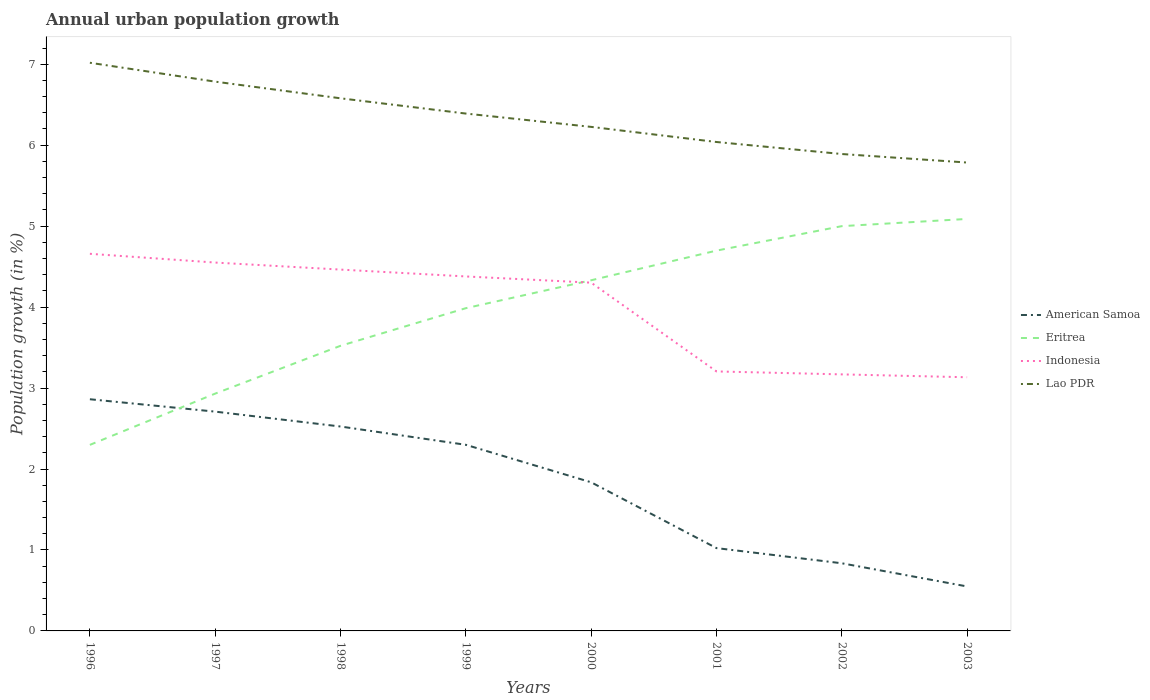How many different coloured lines are there?
Provide a succinct answer. 4. Is the number of lines equal to the number of legend labels?
Provide a succinct answer. Yes. Across all years, what is the maximum percentage of urban population growth in Indonesia?
Offer a terse response. 3.13. In which year was the percentage of urban population growth in Lao PDR maximum?
Your answer should be compact. 2003. What is the total percentage of urban population growth in American Samoa in the graph?
Keep it short and to the point. 2.16. What is the difference between the highest and the second highest percentage of urban population growth in Indonesia?
Your answer should be compact. 1.52. How many years are there in the graph?
Provide a short and direct response. 8. What is the difference between two consecutive major ticks on the Y-axis?
Keep it short and to the point. 1. Are the values on the major ticks of Y-axis written in scientific E-notation?
Provide a short and direct response. No. Where does the legend appear in the graph?
Provide a short and direct response. Center right. How are the legend labels stacked?
Offer a very short reply. Vertical. What is the title of the graph?
Provide a short and direct response. Annual urban population growth. Does "Namibia" appear as one of the legend labels in the graph?
Keep it short and to the point. No. What is the label or title of the X-axis?
Ensure brevity in your answer.  Years. What is the label or title of the Y-axis?
Keep it short and to the point. Population growth (in %). What is the Population growth (in %) in American Samoa in 1996?
Provide a short and direct response. 2.86. What is the Population growth (in %) of Eritrea in 1996?
Provide a succinct answer. 2.3. What is the Population growth (in %) in Indonesia in 1996?
Your answer should be compact. 4.66. What is the Population growth (in %) in Lao PDR in 1996?
Provide a short and direct response. 7.02. What is the Population growth (in %) in American Samoa in 1997?
Offer a very short reply. 2.71. What is the Population growth (in %) in Eritrea in 1997?
Offer a terse response. 2.93. What is the Population growth (in %) of Indonesia in 1997?
Offer a very short reply. 4.55. What is the Population growth (in %) of Lao PDR in 1997?
Your answer should be very brief. 6.78. What is the Population growth (in %) in American Samoa in 1998?
Offer a very short reply. 2.52. What is the Population growth (in %) of Eritrea in 1998?
Make the answer very short. 3.52. What is the Population growth (in %) of Indonesia in 1998?
Ensure brevity in your answer.  4.46. What is the Population growth (in %) of Lao PDR in 1998?
Your answer should be compact. 6.58. What is the Population growth (in %) in American Samoa in 1999?
Ensure brevity in your answer.  2.3. What is the Population growth (in %) in Eritrea in 1999?
Your response must be concise. 3.99. What is the Population growth (in %) in Indonesia in 1999?
Your answer should be very brief. 4.38. What is the Population growth (in %) in Lao PDR in 1999?
Ensure brevity in your answer.  6.39. What is the Population growth (in %) in American Samoa in 2000?
Keep it short and to the point. 1.84. What is the Population growth (in %) of Eritrea in 2000?
Keep it short and to the point. 4.33. What is the Population growth (in %) of Indonesia in 2000?
Offer a terse response. 4.3. What is the Population growth (in %) in Lao PDR in 2000?
Make the answer very short. 6.23. What is the Population growth (in %) of American Samoa in 2001?
Offer a very short reply. 1.02. What is the Population growth (in %) in Eritrea in 2001?
Offer a very short reply. 4.7. What is the Population growth (in %) of Indonesia in 2001?
Your response must be concise. 3.21. What is the Population growth (in %) of Lao PDR in 2001?
Give a very brief answer. 6.04. What is the Population growth (in %) in American Samoa in 2002?
Provide a succinct answer. 0.84. What is the Population growth (in %) of Eritrea in 2002?
Offer a terse response. 5. What is the Population growth (in %) of Indonesia in 2002?
Your answer should be very brief. 3.17. What is the Population growth (in %) of Lao PDR in 2002?
Give a very brief answer. 5.89. What is the Population growth (in %) in American Samoa in 2003?
Make the answer very short. 0.55. What is the Population growth (in %) in Eritrea in 2003?
Offer a terse response. 5.09. What is the Population growth (in %) of Indonesia in 2003?
Offer a terse response. 3.13. What is the Population growth (in %) in Lao PDR in 2003?
Offer a very short reply. 5.79. Across all years, what is the maximum Population growth (in %) in American Samoa?
Give a very brief answer. 2.86. Across all years, what is the maximum Population growth (in %) in Eritrea?
Provide a short and direct response. 5.09. Across all years, what is the maximum Population growth (in %) in Indonesia?
Offer a terse response. 4.66. Across all years, what is the maximum Population growth (in %) of Lao PDR?
Give a very brief answer. 7.02. Across all years, what is the minimum Population growth (in %) in American Samoa?
Your answer should be very brief. 0.55. Across all years, what is the minimum Population growth (in %) of Eritrea?
Your answer should be compact. 2.3. Across all years, what is the minimum Population growth (in %) of Indonesia?
Make the answer very short. 3.13. Across all years, what is the minimum Population growth (in %) in Lao PDR?
Offer a very short reply. 5.79. What is the total Population growth (in %) in American Samoa in the graph?
Provide a succinct answer. 14.64. What is the total Population growth (in %) of Eritrea in the graph?
Your response must be concise. 31.85. What is the total Population growth (in %) in Indonesia in the graph?
Make the answer very short. 31.86. What is the total Population growth (in %) in Lao PDR in the graph?
Give a very brief answer. 50.71. What is the difference between the Population growth (in %) of American Samoa in 1996 and that in 1997?
Provide a short and direct response. 0.15. What is the difference between the Population growth (in %) in Eritrea in 1996 and that in 1997?
Your answer should be compact. -0.63. What is the difference between the Population growth (in %) of Indonesia in 1996 and that in 1997?
Keep it short and to the point. 0.11. What is the difference between the Population growth (in %) in Lao PDR in 1996 and that in 1997?
Your answer should be very brief. 0.23. What is the difference between the Population growth (in %) of American Samoa in 1996 and that in 1998?
Provide a succinct answer. 0.34. What is the difference between the Population growth (in %) in Eritrea in 1996 and that in 1998?
Offer a terse response. -1.22. What is the difference between the Population growth (in %) in Indonesia in 1996 and that in 1998?
Keep it short and to the point. 0.2. What is the difference between the Population growth (in %) of Lao PDR in 1996 and that in 1998?
Give a very brief answer. 0.44. What is the difference between the Population growth (in %) of American Samoa in 1996 and that in 1999?
Provide a short and direct response. 0.56. What is the difference between the Population growth (in %) of Eritrea in 1996 and that in 1999?
Provide a succinct answer. -1.69. What is the difference between the Population growth (in %) of Indonesia in 1996 and that in 1999?
Make the answer very short. 0.28. What is the difference between the Population growth (in %) of Lao PDR in 1996 and that in 1999?
Your response must be concise. 0.63. What is the difference between the Population growth (in %) in American Samoa in 1996 and that in 2000?
Provide a short and direct response. 1.03. What is the difference between the Population growth (in %) in Eritrea in 1996 and that in 2000?
Offer a terse response. -2.03. What is the difference between the Population growth (in %) in Indonesia in 1996 and that in 2000?
Offer a very short reply. 0.36. What is the difference between the Population growth (in %) in Lao PDR in 1996 and that in 2000?
Offer a very short reply. 0.79. What is the difference between the Population growth (in %) in American Samoa in 1996 and that in 2001?
Your answer should be very brief. 1.84. What is the difference between the Population growth (in %) in Eritrea in 1996 and that in 2001?
Offer a terse response. -2.4. What is the difference between the Population growth (in %) in Indonesia in 1996 and that in 2001?
Offer a very short reply. 1.45. What is the difference between the Population growth (in %) in Lao PDR in 1996 and that in 2001?
Give a very brief answer. 0.98. What is the difference between the Population growth (in %) of American Samoa in 1996 and that in 2002?
Your response must be concise. 2.03. What is the difference between the Population growth (in %) in Eritrea in 1996 and that in 2002?
Your answer should be compact. -2.7. What is the difference between the Population growth (in %) of Indonesia in 1996 and that in 2002?
Ensure brevity in your answer.  1.49. What is the difference between the Population growth (in %) of Lao PDR in 1996 and that in 2002?
Keep it short and to the point. 1.13. What is the difference between the Population growth (in %) in American Samoa in 1996 and that in 2003?
Your response must be concise. 2.31. What is the difference between the Population growth (in %) of Eritrea in 1996 and that in 2003?
Give a very brief answer. -2.79. What is the difference between the Population growth (in %) of Indonesia in 1996 and that in 2003?
Offer a very short reply. 1.52. What is the difference between the Population growth (in %) in Lao PDR in 1996 and that in 2003?
Your answer should be compact. 1.23. What is the difference between the Population growth (in %) of American Samoa in 1997 and that in 1998?
Your answer should be compact. 0.18. What is the difference between the Population growth (in %) of Eritrea in 1997 and that in 1998?
Your answer should be compact. -0.59. What is the difference between the Population growth (in %) in Indonesia in 1997 and that in 1998?
Your answer should be very brief. 0.09. What is the difference between the Population growth (in %) in Lao PDR in 1997 and that in 1998?
Offer a very short reply. 0.21. What is the difference between the Population growth (in %) of American Samoa in 1997 and that in 1999?
Provide a succinct answer. 0.41. What is the difference between the Population growth (in %) in Eritrea in 1997 and that in 1999?
Provide a short and direct response. -1.06. What is the difference between the Population growth (in %) in Indonesia in 1997 and that in 1999?
Provide a succinct answer. 0.17. What is the difference between the Population growth (in %) in Lao PDR in 1997 and that in 1999?
Offer a very short reply. 0.39. What is the difference between the Population growth (in %) of American Samoa in 1997 and that in 2000?
Your answer should be compact. 0.87. What is the difference between the Population growth (in %) in Eritrea in 1997 and that in 2000?
Ensure brevity in your answer.  -1.4. What is the difference between the Population growth (in %) in Indonesia in 1997 and that in 2000?
Your answer should be very brief. 0.25. What is the difference between the Population growth (in %) in Lao PDR in 1997 and that in 2000?
Ensure brevity in your answer.  0.56. What is the difference between the Population growth (in %) in American Samoa in 1997 and that in 2001?
Your answer should be very brief. 1.69. What is the difference between the Population growth (in %) in Eritrea in 1997 and that in 2001?
Provide a succinct answer. -1.77. What is the difference between the Population growth (in %) of Indonesia in 1997 and that in 2001?
Provide a short and direct response. 1.34. What is the difference between the Population growth (in %) in Lao PDR in 1997 and that in 2001?
Provide a short and direct response. 0.75. What is the difference between the Population growth (in %) in American Samoa in 1997 and that in 2002?
Your response must be concise. 1.87. What is the difference between the Population growth (in %) in Eritrea in 1997 and that in 2002?
Offer a terse response. -2.07. What is the difference between the Population growth (in %) in Indonesia in 1997 and that in 2002?
Provide a short and direct response. 1.38. What is the difference between the Population growth (in %) in Lao PDR in 1997 and that in 2002?
Your answer should be very brief. 0.89. What is the difference between the Population growth (in %) of American Samoa in 1997 and that in 2003?
Your response must be concise. 2.16. What is the difference between the Population growth (in %) in Eritrea in 1997 and that in 2003?
Ensure brevity in your answer.  -2.16. What is the difference between the Population growth (in %) of Indonesia in 1997 and that in 2003?
Your response must be concise. 1.42. What is the difference between the Population growth (in %) in Lao PDR in 1997 and that in 2003?
Your answer should be compact. 1. What is the difference between the Population growth (in %) of American Samoa in 1998 and that in 1999?
Keep it short and to the point. 0.23. What is the difference between the Population growth (in %) in Eritrea in 1998 and that in 1999?
Provide a succinct answer. -0.46. What is the difference between the Population growth (in %) in Indonesia in 1998 and that in 1999?
Your answer should be very brief. 0.08. What is the difference between the Population growth (in %) in Lao PDR in 1998 and that in 1999?
Your response must be concise. 0.19. What is the difference between the Population growth (in %) in American Samoa in 1998 and that in 2000?
Ensure brevity in your answer.  0.69. What is the difference between the Population growth (in %) of Eritrea in 1998 and that in 2000?
Give a very brief answer. -0.81. What is the difference between the Population growth (in %) of Indonesia in 1998 and that in 2000?
Provide a succinct answer. 0.16. What is the difference between the Population growth (in %) in Lao PDR in 1998 and that in 2000?
Offer a very short reply. 0.35. What is the difference between the Population growth (in %) in American Samoa in 1998 and that in 2001?
Your answer should be compact. 1.5. What is the difference between the Population growth (in %) of Eritrea in 1998 and that in 2001?
Give a very brief answer. -1.18. What is the difference between the Population growth (in %) in Indonesia in 1998 and that in 2001?
Provide a short and direct response. 1.26. What is the difference between the Population growth (in %) of Lao PDR in 1998 and that in 2001?
Your answer should be compact. 0.54. What is the difference between the Population growth (in %) in American Samoa in 1998 and that in 2002?
Keep it short and to the point. 1.69. What is the difference between the Population growth (in %) of Eritrea in 1998 and that in 2002?
Your answer should be compact. -1.48. What is the difference between the Population growth (in %) of Indonesia in 1998 and that in 2002?
Offer a very short reply. 1.29. What is the difference between the Population growth (in %) of Lao PDR in 1998 and that in 2002?
Your response must be concise. 0.69. What is the difference between the Population growth (in %) in American Samoa in 1998 and that in 2003?
Provide a succinct answer. 1.98. What is the difference between the Population growth (in %) in Eritrea in 1998 and that in 2003?
Give a very brief answer. -1.57. What is the difference between the Population growth (in %) of Indonesia in 1998 and that in 2003?
Provide a succinct answer. 1.33. What is the difference between the Population growth (in %) in Lao PDR in 1998 and that in 2003?
Provide a succinct answer. 0.79. What is the difference between the Population growth (in %) of American Samoa in 1999 and that in 2000?
Make the answer very short. 0.46. What is the difference between the Population growth (in %) of Eritrea in 1999 and that in 2000?
Your response must be concise. -0.34. What is the difference between the Population growth (in %) of Indonesia in 1999 and that in 2000?
Ensure brevity in your answer.  0.08. What is the difference between the Population growth (in %) of Lao PDR in 1999 and that in 2000?
Offer a terse response. 0.16. What is the difference between the Population growth (in %) in American Samoa in 1999 and that in 2001?
Your response must be concise. 1.28. What is the difference between the Population growth (in %) of Eritrea in 1999 and that in 2001?
Your response must be concise. -0.71. What is the difference between the Population growth (in %) in Indonesia in 1999 and that in 2001?
Keep it short and to the point. 1.17. What is the difference between the Population growth (in %) of Lao PDR in 1999 and that in 2001?
Provide a short and direct response. 0.35. What is the difference between the Population growth (in %) in American Samoa in 1999 and that in 2002?
Provide a short and direct response. 1.46. What is the difference between the Population growth (in %) in Eritrea in 1999 and that in 2002?
Your answer should be compact. -1.01. What is the difference between the Population growth (in %) in Indonesia in 1999 and that in 2002?
Your answer should be very brief. 1.21. What is the difference between the Population growth (in %) in Lao PDR in 1999 and that in 2002?
Keep it short and to the point. 0.5. What is the difference between the Population growth (in %) in American Samoa in 1999 and that in 2003?
Your answer should be compact. 1.75. What is the difference between the Population growth (in %) of Eritrea in 1999 and that in 2003?
Your response must be concise. -1.1. What is the difference between the Population growth (in %) in Indonesia in 1999 and that in 2003?
Your response must be concise. 1.25. What is the difference between the Population growth (in %) in Lao PDR in 1999 and that in 2003?
Keep it short and to the point. 0.6. What is the difference between the Population growth (in %) of American Samoa in 2000 and that in 2001?
Make the answer very short. 0.81. What is the difference between the Population growth (in %) of Eritrea in 2000 and that in 2001?
Keep it short and to the point. -0.37. What is the difference between the Population growth (in %) of Indonesia in 2000 and that in 2001?
Your answer should be compact. 1.1. What is the difference between the Population growth (in %) in Lao PDR in 2000 and that in 2001?
Your answer should be compact. 0.19. What is the difference between the Population growth (in %) in Eritrea in 2000 and that in 2002?
Give a very brief answer. -0.67. What is the difference between the Population growth (in %) in Indonesia in 2000 and that in 2002?
Keep it short and to the point. 1.13. What is the difference between the Population growth (in %) in Lao PDR in 2000 and that in 2002?
Make the answer very short. 0.34. What is the difference between the Population growth (in %) of American Samoa in 2000 and that in 2003?
Provide a succinct answer. 1.29. What is the difference between the Population growth (in %) of Eritrea in 2000 and that in 2003?
Offer a terse response. -0.76. What is the difference between the Population growth (in %) of Indonesia in 2000 and that in 2003?
Your answer should be compact. 1.17. What is the difference between the Population growth (in %) in Lao PDR in 2000 and that in 2003?
Your response must be concise. 0.44. What is the difference between the Population growth (in %) of American Samoa in 2001 and that in 2002?
Your response must be concise. 0.19. What is the difference between the Population growth (in %) in Eritrea in 2001 and that in 2002?
Your response must be concise. -0.3. What is the difference between the Population growth (in %) in Indonesia in 2001 and that in 2002?
Your answer should be compact. 0.04. What is the difference between the Population growth (in %) in Lao PDR in 2001 and that in 2002?
Keep it short and to the point. 0.15. What is the difference between the Population growth (in %) of American Samoa in 2001 and that in 2003?
Offer a terse response. 0.47. What is the difference between the Population growth (in %) of Eritrea in 2001 and that in 2003?
Your answer should be very brief. -0.39. What is the difference between the Population growth (in %) in Indonesia in 2001 and that in 2003?
Your answer should be compact. 0.07. What is the difference between the Population growth (in %) of Lao PDR in 2001 and that in 2003?
Your answer should be compact. 0.25. What is the difference between the Population growth (in %) of American Samoa in 2002 and that in 2003?
Your answer should be very brief. 0.29. What is the difference between the Population growth (in %) in Eritrea in 2002 and that in 2003?
Offer a very short reply. -0.09. What is the difference between the Population growth (in %) in Indonesia in 2002 and that in 2003?
Your response must be concise. 0.04. What is the difference between the Population growth (in %) in Lao PDR in 2002 and that in 2003?
Keep it short and to the point. 0.11. What is the difference between the Population growth (in %) in American Samoa in 1996 and the Population growth (in %) in Eritrea in 1997?
Offer a terse response. -0.07. What is the difference between the Population growth (in %) of American Samoa in 1996 and the Population growth (in %) of Indonesia in 1997?
Your answer should be compact. -1.69. What is the difference between the Population growth (in %) in American Samoa in 1996 and the Population growth (in %) in Lao PDR in 1997?
Ensure brevity in your answer.  -3.92. What is the difference between the Population growth (in %) in Eritrea in 1996 and the Population growth (in %) in Indonesia in 1997?
Your response must be concise. -2.25. What is the difference between the Population growth (in %) of Eritrea in 1996 and the Population growth (in %) of Lao PDR in 1997?
Ensure brevity in your answer.  -4.49. What is the difference between the Population growth (in %) in Indonesia in 1996 and the Population growth (in %) in Lao PDR in 1997?
Offer a very short reply. -2.13. What is the difference between the Population growth (in %) in American Samoa in 1996 and the Population growth (in %) in Eritrea in 1998?
Your response must be concise. -0.66. What is the difference between the Population growth (in %) in American Samoa in 1996 and the Population growth (in %) in Indonesia in 1998?
Give a very brief answer. -1.6. What is the difference between the Population growth (in %) of American Samoa in 1996 and the Population growth (in %) of Lao PDR in 1998?
Offer a very short reply. -3.72. What is the difference between the Population growth (in %) in Eritrea in 1996 and the Population growth (in %) in Indonesia in 1998?
Make the answer very short. -2.17. What is the difference between the Population growth (in %) in Eritrea in 1996 and the Population growth (in %) in Lao PDR in 1998?
Give a very brief answer. -4.28. What is the difference between the Population growth (in %) in Indonesia in 1996 and the Population growth (in %) in Lao PDR in 1998?
Provide a short and direct response. -1.92. What is the difference between the Population growth (in %) of American Samoa in 1996 and the Population growth (in %) of Eritrea in 1999?
Ensure brevity in your answer.  -1.12. What is the difference between the Population growth (in %) of American Samoa in 1996 and the Population growth (in %) of Indonesia in 1999?
Your answer should be very brief. -1.52. What is the difference between the Population growth (in %) in American Samoa in 1996 and the Population growth (in %) in Lao PDR in 1999?
Make the answer very short. -3.53. What is the difference between the Population growth (in %) of Eritrea in 1996 and the Population growth (in %) of Indonesia in 1999?
Make the answer very short. -2.08. What is the difference between the Population growth (in %) in Eritrea in 1996 and the Population growth (in %) in Lao PDR in 1999?
Make the answer very short. -4.09. What is the difference between the Population growth (in %) in Indonesia in 1996 and the Population growth (in %) in Lao PDR in 1999?
Provide a short and direct response. -1.73. What is the difference between the Population growth (in %) in American Samoa in 1996 and the Population growth (in %) in Eritrea in 2000?
Make the answer very short. -1.47. What is the difference between the Population growth (in %) in American Samoa in 1996 and the Population growth (in %) in Indonesia in 2000?
Your answer should be very brief. -1.44. What is the difference between the Population growth (in %) in American Samoa in 1996 and the Population growth (in %) in Lao PDR in 2000?
Provide a short and direct response. -3.36. What is the difference between the Population growth (in %) of Eritrea in 1996 and the Population growth (in %) of Indonesia in 2000?
Ensure brevity in your answer.  -2. What is the difference between the Population growth (in %) of Eritrea in 1996 and the Population growth (in %) of Lao PDR in 2000?
Offer a terse response. -3.93. What is the difference between the Population growth (in %) of Indonesia in 1996 and the Population growth (in %) of Lao PDR in 2000?
Offer a very short reply. -1.57. What is the difference between the Population growth (in %) in American Samoa in 1996 and the Population growth (in %) in Eritrea in 2001?
Ensure brevity in your answer.  -1.84. What is the difference between the Population growth (in %) in American Samoa in 1996 and the Population growth (in %) in Indonesia in 2001?
Keep it short and to the point. -0.34. What is the difference between the Population growth (in %) of American Samoa in 1996 and the Population growth (in %) of Lao PDR in 2001?
Provide a short and direct response. -3.18. What is the difference between the Population growth (in %) of Eritrea in 1996 and the Population growth (in %) of Indonesia in 2001?
Your answer should be very brief. -0.91. What is the difference between the Population growth (in %) in Eritrea in 1996 and the Population growth (in %) in Lao PDR in 2001?
Offer a very short reply. -3.74. What is the difference between the Population growth (in %) in Indonesia in 1996 and the Population growth (in %) in Lao PDR in 2001?
Ensure brevity in your answer.  -1.38. What is the difference between the Population growth (in %) in American Samoa in 1996 and the Population growth (in %) in Eritrea in 2002?
Provide a succinct answer. -2.14. What is the difference between the Population growth (in %) of American Samoa in 1996 and the Population growth (in %) of Indonesia in 2002?
Provide a succinct answer. -0.31. What is the difference between the Population growth (in %) of American Samoa in 1996 and the Population growth (in %) of Lao PDR in 2002?
Keep it short and to the point. -3.03. What is the difference between the Population growth (in %) of Eritrea in 1996 and the Population growth (in %) of Indonesia in 2002?
Offer a very short reply. -0.87. What is the difference between the Population growth (in %) of Eritrea in 1996 and the Population growth (in %) of Lao PDR in 2002?
Keep it short and to the point. -3.59. What is the difference between the Population growth (in %) of Indonesia in 1996 and the Population growth (in %) of Lao PDR in 2002?
Make the answer very short. -1.23. What is the difference between the Population growth (in %) in American Samoa in 1996 and the Population growth (in %) in Eritrea in 2003?
Your answer should be very brief. -2.23. What is the difference between the Population growth (in %) of American Samoa in 1996 and the Population growth (in %) of Indonesia in 2003?
Make the answer very short. -0.27. What is the difference between the Population growth (in %) of American Samoa in 1996 and the Population growth (in %) of Lao PDR in 2003?
Make the answer very short. -2.92. What is the difference between the Population growth (in %) of Eritrea in 1996 and the Population growth (in %) of Indonesia in 2003?
Your answer should be very brief. -0.84. What is the difference between the Population growth (in %) in Eritrea in 1996 and the Population growth (in %) in Lao PDR in 2003?
Your response must be concise. -3.49. What is the difference between the Population growth (in %) of Indonesia in 1996 and the Population growth (in %) of Lao PDR in 2003?
Provide a short and direct response. -1.13. What is the difference between the Population growth (in %) in American Samoa in 1997 and the Population growth (in %) in Eritrea in 1998?
Keep it short and to the point. -0.81. What is the difference between the Population growth (in %) of American Samoa in 1997 and the Population growth (in %) of Indonesia in 1998?
Offer a very short reply. -1.75. What is the difference between the Population growth (in %) in American Samoa in 1997 and the Population growth (in %) in Lao PDR in 1998?
Ensure brevity in your answer.  -3.87. What is the difference between the Population growth (in %) in Eritrea in 1997 and the Population growth (in %) in Indonesia in 1998?
Provide a succinct answer. -1.53. What is the difference between the Population growth (in %) in Eritrea in 1997 and the Population growth (in %) in Lao PDR in 1998?
Give a very brief answer. -3.65. What is the difference between the Population growth (in %) of Indonesia in 1997 and the Population growth (in %) of Lao PDR in 1998?
Provide a succinct answer. -2.03. What is the difference between the Population growth (in %) in American Samoa in 1997 and the Population growth (in %) in Eritrea in 1999?
Make the answer very short. -1.28. What is the difference between the Population growth (in %) in American Samoa in 1997 and the Population growth (in %) in Indonesia in 1999?
Your answer should be compact. -1.67. What is the difference between the Population growth (in %) of American Samoa in 1997 and the Population growth (in %) of Lao PDR in 1999?
Make the answer very short. -3.68. What is the difference between the Population growth (in %) of Eritrea in 1997 and the Population growth (in %) of Indonesia in 1999?
Ensure brevity in your answer.  -1.45. What is the difference between the Population growth (in %) of Eritrea in 1997 and the Population growth (in %) of Lao PDR in 1999?
Make the answer very short. -3.46. What is the difference between the Population growth (in %) of Indonesia in 1997 and the Population growth (in %) of Lao PDR in 1999?
Keep it short and to the point. -1.84. What is the difference between the Population growth (in %) of American Samoa in 1997 and the Population growth (in %) of Eritrea in 2000?
Provide a short and direct response. -1.62. What is the difference between the Population growth (in %) in American Samoa in 1997 and the Population growth (in %) in Indonesia in 2000?
Offer a terse response. -1.59. What is the difference between the Population growth (in %) in American Samoa in 1997 and the Population growth (in %) in Lao PDR in 2000?
Your response must be concise. -3.52. What is the difference between the Population growth (in %) in Eritrea in 1997 and the Population growth (in %) in Indonesia in 2000?
Make the answer very short. -1.37. What is the difference between the Population growth (in %) of Eritrea in 1997 and the Population growth (in %) of Lao PDR in 2000?
Make the answer very short. -3.29. What is the difference between the Population growth (in %) in Indonesia in 1997 and the Population growth (in %) in Lao PDR in 2000?
Provide a succinct answer. -1.68. What is the difference between the Population growth (in %) in American Samoa in 1997 and the Population growth (in %) in Eritrea in 2001?
Provide a short and direct response. -1.99. What is the difference between the Population growth (in %) in American Samoa in 1997 and the Population growth (in %) in Indonesia in 2001?
Your answer should be very brief. -0.5. What is the difference between the Population growth (in %) of American Samoa in 1997 and the Population growth (in %) of Lao PDR in 2001?
Keep it short and to the point. -3.33. What is the difference between the Population growth (in %) in Eritrea in 1997 and the Population growth (in %) in Indonesia in 2001?
Give a very brief answer. -0.27. What is the difference between the Population growth (in %) of Eritrea in 1997 and the Population growth (in %) of Lao PDR in 2001?
Provide a succinct answer. -3.11. What is the difference between the Population growth (in %) in Indonesia in 1997 and the Population growth (in %) in Lao PDR in 2001?
Give a very brief answer. -1.49. What is the difference between the Population growth (in %) of American Samoa in 1997 and the Population growth (in %) of Eritrea in 2002?
Your response must be concise. -2.29. What is the difference between the Population growth (in %) of American Samoa in 1997 and the Population growth (in %) of Indonesia in 2002?
Give a very brief answer. -0.46. What is the difference between the Population growth (in %) in American Samoa in 1997 and the Population growth (in %) in Lao PDR in 2002?
Give a very brief answer. -3.18. What is the difference between the Population growth (in %) of Eritrea in 1997 and the Population growth (in %) of Indonesia in 2002?
Offer a very short reply. -0.24. What is the difference between the Population growth (in %) in Eritrea in 1997 and the Population growth (in %) in Lao PDR in 2002?
Give a very brief answer. -2.96. What is the difference between the Population growth (in %) of Indonesia in 1997 and the Population growth (in %) of Lao PDR in 2002?
Give a very brief answer. -1.34. What is the difference between the Population growth (in %) in American Samoa in 1997 and the Population growth (in %) in Eritrea in 2003?
Your answer should be very brief. -2.38. What is the difference between the Population growth (in %) in American Samoa in 1997 and the Population growth (in %) in Indonesia in 2003?
Provide a short and direct response. -0.42. What is the difference between the Population growth (in %) in American Samoa in 1997 and the Population growth (in %) in Lao PDR in 2003?
Ensure brevity in your answer.  -3.08. What is the difference between the Population growth (in %) in Eritrea in 1997 and the Population growth (in %) in Indonesia in 2003?
Make the answer very short. -0.2. What is the difference between the Population growth (in %) of Eritrea in 1997 and the Population growth (in %) of Lao PDR in 2003?
Offer a very short reply. -2.85. What is the difference between the Population growth (in %) in Indonesia in 1997 and the Population growth (in %) in Lao PDR in 2003?
Your answer should be very brief. -1.24. What is the difference between the Population growth (in %) in American Samoa in 1998 and the Population growth (in %) in Eritrea in 1999?
Provide a succinct answer. -1.46. What is the difference between the Population growth (in %) in American Samoa in 1998 and the Population growth (in %) in Indonesia in 1999?
Ensure brevity in your answer.  -1.85. What is the difference between the Population growth (in %) in American Samoa in 1998 and the Population growth (in %) in Lao PDR in 1999?
Your response must be concise. -3.87. What is the difference between the Population growth (in %) of Eritrea in 1998 and the Population growth (in %) of Indonesia in 1999?
Offer a very short reply. -0.86. What is the difference between the Population growth (in %) in Eritrea in 1998 and the Population growth (in %) in Lao PDR in 1999?
Offer a terse response. -2.87. What is the difference between the Population growth (in %) of Indonesia in 1998 and the Population growth (in %) of Lao PDR in 1999?
Your answer should be compact. -1.93. What is the difference between the Population growth (in %) in American Samoa in 1998 and the Population growth (in %) in Eritrea in 2000?
Keep it short and to the point. -1.81. What is the difference between the Population growth (in %) in American Samoa in 1998 and the Population growth (in %) in Indonesia in 2000?
Make the answer very short. -1.78. What is the difference between the Population growth (in %) of American Samoa in 1998 and the Population growth (in %) of Lao PDR in 2000?
Your response must be concise. -3.7. What is the difference between the Population growth (in %) of Eritrea in 1998 and the Population growth (in %) of Indonesia in 2000?
Provide a short and direct response. -0.78. What is the difference between the Population growth (in %) of Eritrea in 1998 and the Population growth (in %) of Lao PDR in 2000?
Provide a succinct answer. -2.7. What is the difference between the Population growth (in %) of Indonesia in 1998 and the Population growth (in %) of Lao PDR in 2000?
Give a very brief answer. -1.76. What is the difference between the Population growth (in %) in American Samoa in 1998 and the Population growth (in %) in Eritrea in 2001?
Provide a short and direct response. -2.17. What is the difference between the Population growth (in %) in American Samoa in 1998 and the Population growth (in %) in Indonesia in 2001?
Your answer should be very brief. -0.68. What is the difference between the Population growth (in %) in American Samoa in 1998 and the Population growth (in %) in Lao PDR in 2001?
Ensure brevity in your answer.  -3.51. What is the difference between the Population growth (in %) in Eritrea in 1998 and the Population growth (in %) in Indonesia in 2001?
Give a very brief answer. 0.32. What is the difference between the Population growth (in %) of Eritrea in 1998 and the Population growth (in %) of Lao PDR in 2001?
Offer a very short reply. -2.52. What is the difference between the Population growth (in %) in Indonesia in 1998 and the Population growth (in %) in Lao PDR in 2001?
Keep it short and to the point. -1.58. What is the difference between the Population growth (in %) in American Samoa in 1998 and the Population growth (in %) in Eritrea in 2002?
Your answer should be very brief. -2.47. What is the difference between the Population growth (in %) in American Samoa in 1998 and the Population growth (in %) in Indonesia in 2002?
Give a very brief answer. -0.64. What is the difference between the Population growth (in %) in American Samoa in 1998 and the Population growth (in %) in Lao PDR in 2002?
Your answer should be very brief. -3.37. What is the difference between the Population growth (in %) in Eritrea in 1998 and the Population growth (in %) in Indonesia in 2002?
Keep it short and to the point. 0.35. What is the difference between the Population growth (in %) in Eritrea in 1998 and the Population growth (in %) in Lao PDR in 2002?
Make the answer very short. -2.37. What is the difference between the Population growth (in %) of Indonesia in 1998 and the Population growth (in %) of Lao PDR in 2002?
Provide a succinct answer. -1.43. What is the difference between the Population growth (in %) of American Samoa in 1998 and the Population growth (in %) of Eritrea in 2003?
Give a very brief answer. -2.56. What is the difference between the Population growth (in %) of American Samoa in 1998 and the Population growth (in %) of Indonesia in 2003?
Give a very brief answer. -0.61. What is the difference between the Population growth (in %) of American Samoa in 1998 and the Population growth (in %) of Lao PDR in 2003?
Provide a short and direct response. -3.26. What is the difference between the Population growth (in %) in Eritrea in 1998 and the Population growth (in %) in Indonesia in 2003?
Keep it short and to the point. 0.39. What is the difference between the Population growth (in %) in Eritrea in 1998 and the Population growth (in %) in Lao PDR in 2003?
Your answer should be compact. -2.26. What is the difference between the Population growth (in %) in Indonesia in 1998 and the Population growth (in %) in Lao PDR in 2003?
Keep it short and to the point. -1.32. What is the difference between the Population growth (in %) of American Samoa in 1999 and the Population growth (in %) of Eritrea in 2000?
Give a very brief answer. -2.03. What is the difference between the Population growth (in %) in American Samoa in 1999 and the Population growth (in %) in Indonesia in 2000?
Give a very brief answer. -2. What is the difference between the Population growth (in %) of American Samoa in 1999 and the Population growth (in %) of Lao PDR in 2000?
Give a very brief answer. -3.93. What is the difference between the Population growth (in %) of Eritrea in 1999 and the Population growth (in %) of Indonesia in 2000?
Your response must be concise. -0.32. What is the difference between the Population growth (in %) in Eritrea in 1999 and the Population growth (in %) in Lao PDR in 2000?
Your response must be concise. -2.24. What is the difference between the Population growth (in %) of Indonesia in 1999 and the Population growth (in %) of Lao PDR in 2000?
Your answer should be very brief. -1.85. What is the difference between the Population growth (in %) in American Samoa in 1999 and the Population growth (in %) in Eritrea in 2001?
Your answer should be compact. -2.4. What is the difference between the Population growth (in %) in American Samoa in 1999 and the Population growth (in %) in Indonesia in 2001?
Give a very brief answer. -0.91. What is the difference between the Population growth (in %) of American Samoa in 1999 and the Population growth (in %) of Lao PDR in 2001?
Ensure brevity in your answer.  -3.74. What is the difference between the Population growth (in %) in Eritrea in 1999 and the Population growth (in %) in Indonesia in 2001?
Provide a short and direct response. 0.78. What is the difference between the Population growth (in %) of Eritrea in 1999 and the Population growth (in %) of Lao PDR in 2001?
Your response must be concise. -2.05. What is the difference between the Population growth (in %) in Indonesia in 1999 and the Population growth (in %) in Lao PDR in 2001?
Offer a very short reply. -1.66. What is the difference between the Population growth (in %) in American Samoa in 1999 and the Population growth (in %) in Eritrea in 2002?
Keep it short and to the point. -2.7. What is the difference between the Population growth (in %) in American Samoa in 1999 and the Population growth (in %) in Indonesia in 2002?
Your answer should be compact. -0.87. What is the difference between the Population growth (in %) of American Samoa in 1999 and the Population growth (in %) of Lao PDR in 2002?
Keep it short and to the point. -3.59. What is the difference between the Population growth (in %) in Eritrea in 1999 and the Population growth (in %) in Indonesia in 2002?
Your answer should be compact. 0.82. What is the difference between the Population growth (in %) in Eritrea in 1999 and the Population growth (in %) in Lao PDR in 2002?
Make the answer very short. -1.9. What is the difference between the Population growth (in %) in Indonesia in 1999 and the Population growth (in %) in Lao PDR in 2002?
Make the answer very short. -1.51. What is the difference between the Population growth (in %) in American Samoa in 1999 and the Population growth (in %) in Eritrea in 2003?
Ensure brevity in your answer.  -2.79. What is the difference between the Population growth (in %) of American Samoa in 1999 and the Population growth (in %) of Indonesia in 2003?
Provide a short and direct response. -0.83. What is the difference between the Population growth (in %) of American Samoa in 1999 and the Population growth (in %) of Lao PDR in 2003?
Offer a terse response. -3.49. What is the difference between the Population growth (in %) of Eritrea in 1999 and the Population growth (in %) of Indonesia in 2003?
Make the answer very short. 0.85. What is the difference between the Population growth (in %) in Eritrea in 1999 and the Population growth (in %) in Lao PDR in 2003?
Offer a very short reply. -1.8. What is the difference between the Population growth (in %) in Indonesia in 1999 and the Population growth (in %) in Lao PDR in 2003?
Provide a succinct answer. -1.41. What is the difference between the Population growth (in %) of American Samoa in 2000 and the Population growth (in %) of Eritrea in 2001?
Your answer should be very brief. -2.86. What is the difference between the Population growth (in %) of American Samoa in 2000 and the Population growth (in %) of Indonesia in 2001?
Make the answer very short. -1.37. What is the difference between the Population growth (in %) in American Samoa in 2000 and the Population growth (in %) in Lao PDR in 2001?
Give a very brief answer. -4.2. What is the difference between the Population growth (in %) in Eritrea in 2000 and the Population growth (in %) in Indonesia in 2001?
Keep it short and to the point. 1.13. What is the difference between the Population growth (in %) in Eritrea in 2000 and the Population growth (in %) in Lao PDR in 2001?
Provide a succinct answer. -1.71. What is the difference between the Population growth (in %) of Indonesia in 2000 and the Population growth (in %) of Lao PDR in 2001?
Offer a terse response. -1.74. What is the difference between the Population growth (in %) of American Samoa in 2000 and the Population growth (in %) of Eritrea in 2002?
Keep it short and to the point. -3.16. What is the difference between the Population growth (in %) of American Samoa in 2000 and the Population growth (in %) of Indonesia in 2002?
Ensure brevity in your answer.  -1.33. What is the difference between the Population growth (in %) of American Samoa in 2000 and the Population growth (in %) of Lao PDR in 2002?
Keep it short and to the point. -4.05. What is the difference between the Population growth (in %) of Eritrea in 2000 and the Population growth (in %) of Indonesia in 2002?
Your answer should be very brief. 1.16. What is the difference between the Population growth (in %) in Eritrea in 2000 and the Population growth (in %) in Lao PDR in 2002?
Make the answer very short. -1.56. What is the difference between the Population growth (in %) in Indonesia in 2000 and the Population growth (in %) in Lao PDR in 2002?
Give a very brief answer. -1.59. What is the difference between the Population growth (in %) of American Samoa in 2000 and the Population growth (in %) of Eritrea in 2003?
Keep it short and to the point. -3.25. What is the difference between the Population growth (in %) of American Samoa in 2000 and the Population growth (in %) of Indonesia in 2003?
Offer a terse response. -1.3. What is the difference between the Population growth (in %) of American Samoa in 2000 and the Population growth (in %) of Lao PDR in 2003?
Ensure brevity in your answer.  -3.95. What is the difference between the Population growth (in %) in Eritrea in 2000 and the Population growth (in %) in Indonesia in 2003?
Offer a very short reply. 1.2. What is the difference between the Population growth (in %) of Eritrea in 2000 and the Population growth (in %) of Lao PDR in 2003?
Offer a very short reply. -1.45. What is the difference between the Population growth (in %) of Indonesia in 2000 and the Population growth (in %) of Lao PDR in 2003?
Ensure brevity in your answer.  -1.48. What is the difference between the Population growth (in %) in American Samoa in 2001 and the Population growth (in %) in Eritrea in 2002?
Ensure brevity in your answer.  -3.98. What is the difference between the Population growth (in %) of American Samoa in 2001 and the Population growth (in %) of Indonesia in 2002?
Your answer should be compact. -2.15. What is the difference between the Population growth (in %) of American Samoa in 2001 and the Population growth (in %) of Lao PDR in 2002?
Provide a short and direct response. -4.87. What is the difference between the Population growth (in %) of Eritrea in 2001 and the Population growth (in %) of Indonesia in 2002?
Make the answer very short. 1.53. What is the difference between the Population growth (in %) in Eritrea in 2001 and the Population growth (in %) in Lao PDR in 2002?
Provide a short and direct response. -1.19. What is the difference between the Population growth (in %) of Indonesia in 2001 and the Population growth (in %) of Lao PDR in 2002?
Your answer should be very brief. -2.69. What is the difference between the Population growth (in %) in American Samoa in 2001 and the Population growth (in %) in Eritrea in 2003?
Your answer should be compact. -4.07. What is the difference between the Population growth (in %) in American Samoa in 2001 and the Population growth (in %) in Indonesia in 2003?
Provide a short and direct response. -2.11. What is the difference between the Population growth (in %) of American Samoa in 2001 and the Population growth (in %) of Lao PDR in 2003?
Offer a very short reply. -4.76. What is the difference between the Population growth (in %) of Eritrea in 2001 and the Population growth (in %) of Indonesia in 2003?
Your answer should be very brief. 1.56. What is the difference between the Population growth (in %) in Eritrea in 2001 and the Population growth (in %) in Lao PDR in 2003?
Offer a very short reply. -1.09. What is the difference between the Population growth (in %) in Indonesia in 2001 and the Population growth (in %) in Lao PDR in 2003?
Offer a very short reply. -2.58. What is the difference between the Population growth (in %) of American Samoa in 2002 and the Population growth (in %) of Eritrea in 2003?
Provide a short and direct response. -4.25. What is the difference between the Population growth (in %) of American Samoa in 2002 and the Population growth (in %) of Indonesia in 2003?
Your answer should be very brief. -2.3. What is the difference between the Population growth (in %) of American Samoa in 2002 and the Population growth (in %) of Lao PDR in 2003?
Keep it short and to the point. -4.95. What is the difference between the Population growth (in %) of Eritrea in 2002 and the Population growth (in %) of Indonesia in 2003?
Your answer should be very brief. 1.87. What is the difference between the Population growth (in %) of Eritrea in 2002 and the Population growth (in %) of Lao PDR in 2003?
Give a very brief answer. -0.79. What is the difference between the Population growth (in %) of Indonesia in 2002 and the Population growth (in %) of Lao PDR in 2003?
Offer a terse response. -2.62. What is the average Population growth (in %) of American Samoa per year?
Provide a short and direct response. 1.83. What is the average Population growth (in %) in Eritrea per year?
Your answer should be compact. 3.98. What is the average Population growth (in %) in Indonesia per year?
Provide a succinct answer. 3.98. What is the average Population growth (in %) in Lao PDR per year?
Offer a very short reply. 6.34. In the year 1996, what is the difference between the Population growth (in %) in American Samoa and Population growth (in %) in Eritrea?
Give a very brief answer. 0.56. In the year 1996, what is the difference between the Population growth (in %) in American Samoa and Population growth (in %) in Indonesia?
Provide a succinct answer. -1.8. In the year 1996, what is the difference between the Population growth (in %) in American Samoa and Population growth (in %) in Lao PDR?
Ensure brevity in your answer.  -4.16. In the year 1996, what is the difference between the Population growth (in %) of Eritrea and Population growth (in %) of Indonesia?
Ensure brevity in your answer.  -2.36. In the year 1996, what is the difference between the Population growth (in %) in Eritrea and Population growth (in %) in Lao PDR?
Your response must be concise. -4.72. In the year 1996, what is the difference between the Population growth (in %) of Indonesia and Population growth (in %) of Lao PDR?
Provide a succinct answer. -2.36. In the year 1997, what is the difference between the Population growth (in %) in American Samoa and Population growth (in %) in Eritrea?
Offer a terse response. -0.22. In the year 1997, what is the difference between the Population growth (in %) of American Samoa and Population growth (in %) of Indonesia?
Your answer should be compact. -1.84. In the year 1997, what is the difference between the Population growth (in %) of American Samoa and Population growth (in %) of Lao PDR?
Make the answer very short. -4.08. In the year 1997, what is the difference between the Population growth (in %) in Eritrea and Population growth (in %) in Indonesia?
Ensure brevity in your answer.  -1.62. In the year 1997, what is the difference between the Population growth (in %) of Eritrea and Population growth (in %) of Lao PDR?
Your response must be concise. -3.85. In the year 1997, what is the difference between the Population growth (in %) of Indonesia and Population growth (in %) of Lao PDR?
Provide a short and direct response. -2.23. In the year 1998, what is the difference between the Population growth (in %) of American Samoa and Population growth (in %) of Eritrea?
Ensure brevity in your answer.  -1. In the year 1998, what is the difference between the Population growth (in %) in American Samoa and Population growth (in %) in Indonesia?
Offer a terse response. -1.94. In the year 1998, what is the difference between the Population growth (in %) of American Samoa and Population growth (in %) of Lao PDR?
Provide a short and direct response. -4.05. In the year 1998, what is the difference between the Population growth (in %) in Eritrea and Population growth (in %) in Indonesia?
Offer a very short reply. -0.94. In the year 1998, what is the difference between the Population growth (in %) of Eritrea and Population growth (in %) of Lao PDR?
Offer a very short reply. -3.06. In the year 1998, what is the difference between the Population growth (in %) of Indonesia and Population growth (in %) of Lao PDR?
Your answer should be very brief. -2.12. In the year 1999, what is the difference between the Population growth (in %) in American Samoa and Population growth (in %) in Eritrea?
Make the answer very short. -1.69. In the year 1999, what is the difference between the Population growth (in %) of American Samoa and Population growth (in %) of Indonesia?
Keep it short and to the point. -2.08. In the year 1999, what is the difference between the Population growth (in %) in American Samoa and Population growth (in %) in Lao PDR?
Your answer should be very brief. -4.09. In the year 1999, what is the difference between the Population growth (in %) in Eritrea and Population growth (in %) in Indonesia?
Your answer should be compact. -0.39. In the year 1999, what is the difference between the Population growth (in %) of Eritrea and Population growth (in %) of Lao PDR?
Your answer should be compact. -2.4. In the year 1999, what is the difference between the Population growth (in %) of Indonesia and Population growth (in %) of Lao PDR?
Ensure brevity in your answer.  -2.01. In the year 2000, what is the difference between the Population growth (in %) of American Samoa and Population growth (in %) of Eritrea?
Keep it short and to the point. -2.5. In the year 2000, what is the difference between the Population growth (in %) of American Samoa and Population growth (in %) of Indonesia?
Ensure brevity in your answer.  -2.47. In the year 2000, what is the difference between the Population growth (in %) in American Samoa and Population growth (in %) in Lao PDR?
Ensure brevity in your answer.  -4.39. In the year 2000, what is the difference between the Population growth (in %) in Eritrea and Population growth (in %) in Indonesia?
Provide a short and direct response. 0.03. In the year 2000, what is the difference between the Population growth (in %) in Eritrea and Population growth (in %) in Lao PDR?
Ensure brevity in your answer.  -1.89. In the year 2000, what is the difference between the Population growth (in %) of Indonesia and Population growth (in %) of Lao PDR?
Your answer should be very brief. -1.92. In the year 2001, what is the difference between the Population growth (in %) in American Samoa and Population growth (in %) in Eritrea?
Your response must be concise. -3.67. In the year 2001, what is the difference between the Population growth (in %) of American Samoa and Population growth (in %) of Indonesia?
Give a very brief answer. -2.18. In the year 2001, what is the difference between the Population growth (in %) of American Samoa and Population growth (in %) of Lao PDR?
Offer a terse response. -5.02. In the year 2001, what is the difference between the Population growth (in %) of Eritrea and Population growth (in %) of Indonesia?
Your response must be concise. 1.49. In the year 2001, what is the difference between the Population growth (in %) of Eritrea and Population growth (in %) of Lao PDR?
Provide a short and direct response. -1.34. In the year 2001, what is the difference between the Population growth (in %) of Indonesia and Population growth (in %) of Lao PDR?
Provide a short and direct response. -2.83. In the year 2002, what is the difference between the Population growth (in %) of American Samoa and Population growth (in %) of Eritrea?
Make the answer very short. -4.16. In the year 2002, what is the difference between the Population growth (in %) of American Samoa and Population growth (in %) of Indonesia?
Make the answer very short. -2.33. In the year 2002, what is the difference between the Population growth (in %) in American Samoa and Population growth (in %) in Lao PDR?
Ensure brevity in your answer.  -5.05. In the year 2002, what is the difference between the Population growth (in %) in Eritrea and Population growth (in %) in Indonesia?
Keep it short and to the point. 1.83. In the year 2002, what is the difference between the Population growth (in %) of Eritrea and Population growth (in %) of Lao PDR?
Offer a very short reply. -0.89. In the year 2002, what is the difference between the Population growth (in %) in Indonesia and Population growth (in %) in Lao PDR?
Your response must be concise. -2.72. In the year 2003, what is the difference between the Population growth (in %) in American Samoa and Population growth (in %) in Eritrea?
Your answer should be compact. -4.54. In the year 2003, what is the difference between the Population growth (in %) of American Samoa and Population growth (in %) of Indonesia?
Ensure brevity in your answer.  -2.58. In the year 2003, what is the difference between the Population growth (in %) of American Samoa and Population growth (in %) of Lao PDR?
Provide a short and direct response. -5.24. In the year 2003, what is the difference between the Population growth (in %) of Eritrea and Population growth (in %) of Indonesia?
Make the answer very short. 1.96. In the year 2003, what is the difference between the Population growth (in %) in Eritrea and Population growth (in %) in Lao PDR?
Offer a terse response. -0.7. In the year 2003, what is the difference between the Population growth (in %) in Indonesia and Population growth (in %) in Lao PDR?
Your answer should be very brief. -2.65. What is the ratio of the Population growth (in %) of American Samoa in 1996 to that in 1997?
Ensure brevity in your answer.  1.06. What is the ratio of the Population growth (in %) in Eritrea in 1996 to that in 1997?
Ensure brevity in your answer.  0.78. What is the ratio of the Population growth (in %) in Indonesia in 1996 to that in 1997?
Provide a short and direct response. 1.02. What is the ratio of the Population growth (in %) of Lao PDR in 1996 to that in 1997?
Make the answer very short. 1.03. What is the ratio of the Population growth (in %) of American Samoa in 1996 to that in 1998?
Offer a terse response. 1.13. What is the ratio of the Population growth (in %) of Eritrea in 1996 to that in 1998?
Provide a succinct answer. 0.65. What is the ratio of the Population growth (in %) of Indonesia in 1996 to that in 1998?
Your answer should be compact. 1.04. What is the ratio of the Population growth (in %) of Lao PDR in 1996 to that in 1998?
Your answer should be very brief. 1.07. What is the ratio of the Population growth (in %) of American Samoa in 1996 to that in 1999?
Your answer should be compact. 1.24. What is the ratio of the Population growth (in %) in Eritrea in 1996 to that in 1999?
Offer a very short reply. 0.58. What is the ratio of the Population growth (in %) of Indonesia in 1996 to that in 1999?
Provide a short and direct response. 1.06. What is the ratio of the Population growth (in %) of Lao PDR in 1996 to that in 1999?
Keep it short and to the point. 1.1. What is the ratio of the Population growth (in %) in American Samoa in 1996 to that in 2000?
Ensure brevity in your answer.  1.56. What is the ratio of the Population growth (in %) of Eritrea in 1996 to that in 2000?
Keep it short and to the point. 0.53. What is the ratio of the Population growth (in %) of Indonesia in 1996 to that in 2000?
Keep it short and to the point. 1.08. What is the ratio of the Population growth (in %) in Lao PDR in 1996 to that in 2000?
Offer a terse response. 1.13. What is the ratio of the Population growth (in %) in American Samoa in 1996 to that in 2001?
Provide a short and direct response. 2.8. What is the ratio of the Population growth (in %) in Eritrea in 1996 to that in 2001?
Your answer should be very brief. 0.49. What is the ratio of the Population growth (in %) in Indonesia in 1996 to that in 2001?
Your answer should be compact. 1.45. What is the ratio of the Population growth (in %) of Lao PDR in 1996 to that in 2001?
Offer a terse response. 1.16. What is the ratio of the Population growth (in %) of American Samoa in 1996 to that in 2002?
Your response must be concise. 3.42. What is the ratio of the Population growth (in %) of Eritrea in 1996 to that in 2002?
Ensure brevity in your answer.  0.46. What is the ratio of the Population growth (in %) of Indonesia in 1996 to that in 2002?
Your answer should be very brief. 1.47. What is the ratio of the Population growth (in %) in Lao PDR in 1996 to that in 2002?
Your answer should be compact. 1.19. What is the ratio of the Population growth (in %) in American Samoa in 1996 to that in 2003?
Provide a short and direct response. 5.21. What is the ratio of the Population growth (in %) of Eritrea in 1996 to that in 2003?
Your response must be concise. 0.45. What is the ratio of the Population growth (in %) of Indonesia in 1996 to that in 2003?
Offer a terse response. 1.49. What is the ratio of the Population growth (in %) in Lao PDR in 1996 to that in 2003?
Offer a terse response. 1.21. What is the ratio of the Population growth (in %) in American Samoa in 1997 to that in 1998?
Provide a short and direct response. 1.07. What is the ratio of the Population growth (in %) in Eritrea in 1997 to that in 1998?
Provide a succinct answer. 0.83. What is the ratio of the Population growth (in %) of Indonesia in 1997 to that in 1998?
Provide a short and direct response. 1.02. What is the ratio of the Population growth (in %) in Lao PDR in 1997 to that in 1998?
Your response must be concise. 1.03. What is the ratio of the Population growth (in %) of American Samoa in 1997 to that in 1999?
Provide a succinct answer. 1.18. What is the ratio of the Population growth (in %) of Eritrea in 1997 to that in 1999?
Make the answer very short. 0.74. What is the ratio of the Population growth (in %) of Indonesia in 1997 to that in 1999?
Ensure brevity in your answer.  1.04. What is the ratio of the Population growth (in %) in Lao PDR in 1997 to that in 1999?
Offer a terse response. 1.06. What is the ratio of the Population growth (in %) in American Samoa in 1997 to that in 2000?
Ensure brevity in your answer.  1.48. What is the ratio of the Population growth (in %) of Eritrea in 1997 to that in 2000?
Ensure brevity in your answer.  0.68. What is the ratio of the Population growth (in %) in Indonesia in 1997 to that in 2000?
Provide a succinct answer. 1.06. What is the ratio of the Population growth (in %) in Lao PDR in 1997 to that in 2000?
Offer a very short reply. 1.09. What is the ratio of the Population growth (in %) in American Samoa in 1997 to that in 2001?
Keep it short and to the point. 2.65. What is the ratio of the Population growth (in %) of Eritrea in 1997 to that in 2001?
Your answer should be very brief. 0.62. What is the ratio of the Population growth (in %) of Indonesia in 1997 to that in 2001?
Provide a succinct answer. 1.42. What is the ratio of the Population growth (in %) of Lao PDR in 1997 to that in 2001?
Provide a succinct answer. 1.12. What is the ratio of the Population growth (in %) in American Samoa in 1997 to that in 2002?
Your answer should be compact. 3.24. What is the ratio of the Population growth (in %) in Eritrea in 1997 to that in 2002?
Make the answer very short. 0.59. What is the ratio of the Population growth (in %) of Indonesia in 1997 to that in 2002?
Your response must be concise. 1.44. What is the ratio of the Population growth (in %) in Lao PDR in 1997 to that in 2002?
Your response must be concise. 1.15. What is the ratio of the Population growth (in %) of American Samoa in 1997 to that in 2003?
Keep it short and to the point. 4.93. What is the ratio of the Population growth (in %) of Eritrea in 1997 to that in 2003?
Ensure brevity in your answer.  0.58. What is the ratio of the Population growth (in %) of Indonesia in 1997 to that in 2003?
Provide a succinct answer. 1.45. What is the ratio of the Population growth (in %) in Lao PDR in 1997 to that in 2003?
Ensure brevity in your answer.  1.17. What is the ratio of the Population growth (in %) in American Samoa in 1998 to that in 1999?
Offer a very short reply. 1.1. What is the ratio of the Population growth (in %) in Eritrea in 1998 to that in 1999?
Your response must be concise. 0.88. What is the ratio of the Population growth (in %) of Indonesia in 1998 to that in 1999?
Your response must be concise. 1.02. What is the ratio of the Population growth (in %) of Lao PDR in 1998 to that in 1999?
Your answer should be compact. 1.03. What is the ratio of the Population growth (in %) in American Samoa in 1998 to that in 2000?
Provide a short and direct response. 1.38. What is the ratio of the Population growth (in %) in Eritrea in 1998 to that in 2000?
Keep it short and to the point. 0.81. What is the ratio of the Population growth (in %) of Indonesia in 1998 to that in 2000?
Provide a short and direct response. 1.04. What is the ratio of the Population growth (in %) in Lao PDR in 1998 to that in 2000?
Offer a terse response. 1.06. What is the ratio of the Population growth (in %) of American Samoa in 1998 to that in 2001?
Offer a terse response. 2.47. What is the ratio of the Population growth (in %) in Eritrea in 1998 to that in 2001?
Ensure brevity in your answer.  0.75. What is the ratio of the Population growth (in %) of Indonesia in 1998 to that in 2001?
Provide a succinct answer. 1.39. What is the ratio of the Population growth (in %) of Lao PDR in 1998 to that in 2001?
Give a very brief answer. 1.09. What is the ratio of the Population growth (in %) of American Samoa in 1998 to that in 2002?
Ensure brevity in your answer.  3.02. What is the ratio of the Population growth (in %) in Eritrea in 1998 to that in 2002?
Offer a very short reply. 0.7. What is the ratio of the Population growth (in %) in Indonesia in 1998 to that in 2002?
Your answer should be very brief. 1.41. What is the ratio of the Population growth (in %) of Lao PDR in 1998 to that in 2002?
Ensure brevity in your answer.  1.12. What is the ratio of the Population growth (in %) of American Samoa in 1998 to that in 2003?
Your answer should be very brief. 4.6. What is the ratio of the Population growth (in %) of Eritrea in 1998 to that in 2003?
Ensure brevity in your answer.  0.69. What is the ratio of the Population growth (in %) in Indonesia in 1998 to that in 2003?
Offer a terse response. 1.42. What is the ratio of the Population growth (in %) in Lao PDR in 1998 to that in 2003?
Give a very brief answer. 1.14. What is the ratio of the Population growth (in %) of American Samoa in 1999 to that in 2000?
Your answer should be compact. 1.25. What is the ratio of the Population growth (in %) in Eritrea in 1999 to that in 2000?
Provide a short and direct response. 0.92. What is the ratio of the Population growth (in %) in Indonesia in 1999 to that in 2000?
Your answer should be compact. 1.02. What is the ratio of the Population growth (in %) of Lao PDR in 1999 to that in 2000?
Make the answer very short. 1.03. What is the ratio of the Population growth (in %) of American Samoa in 1999 to that in 2001?
Offer a very short reply. 2.25. What is the ratio of the Population growth (in %) of Eritrea in 1999 to that in 2001?
Keep it short and to the point. 0.85. What is the ratio of the Population growth (in %) of Indonesia in 1999 to that in 2001?
Keep it short and to the point. 1.37. What is the ratio of the Population growth (in %) of Lao PDR in 1999 to that in 2001?
Offer a terse response. 1.06. What is the ratio of the Population growth (in %) of American Samoa in 1999 to that in 2002?
Offer a terse response. 2.75. What is the ratio of the Population growth (in %) of Eritrea in 1999 to that in 2002?
Keep it short and to the point. 0.8. What is the ratio of the Population growth (in %) of Indonesia in 1999 to that in 2002?
Your response must be concise. 1.38. What is the ratio of the Population growth (in %) of Lao PDR in 1999 to that in 2002?
Give a very brief answer. 1.08. What is the ratio of the Population growth (in %) of American Samoa in 1999 to that in 2003?
Ensure brevity in your answer.  4.18. What is the ratio of the Population growth (in %) in Eritrea in 1999 to that in 2003?
Your answer should be compact. 0.78. What is the ratio of the Population growth (in %) of Indonesia in 1999 to that in 2003?
Give a very brief answer. 1.4. What is the ratio of the Population growth (in %) of Lao PDR in 1999 to that in 2003?
Give a very brief answer. 1.1. What is the ratio of the Population growth (in %) in American Samoa in 2000 to that in 2001?
Give a very brief answer. 1.79. What is the ratio of the Population growth (in %) of Eritrea in 2000 to that in 2001?
Provide a succinct answer. 0.92. What is the ratio of the Population growth (in %) of Indonesia in 2000 to that in 2001?
Provide a short and direct response. 1.34. What is the ratio of the Population growth (in %) of Lao PDR in 2000 to that in 2001?
Make the answer very short. 1.03. What is the ratio of the Population growth (in %) in American Samoa in 2000 to that in 2002?
Give a very brief answer. 2.2. What is the ratio of the Population growth (in %) of Eritrea in 2000 to that in 2002?
Ensure brevity in your answer.  0.87. What is the ratio of the Population growth (in %) of Indonesia in 2000 to that in 2002?
Keep it short and to the point. 1.36. What is the ratio of the Population growth (in %) in Lao PDR in 2000 to that in 2002?
Your response must be concise. 1.06. What is the ratio of the Population growth (in %) in American Samoa in 2000 to that in 2003?
Offer a terse response. 3.34. What is the ratio of the Population growth (in %) in Eritrea in 2000 to that in 2003?
Your response must be concise. 0.85. What is the ratio of the Population growth (in %) in Indonesia in 2000 to that in 2003?
Your response must be concise. 1.37. What is the ratio of the Population growth (in %) in Lao PDR in 2000 to that in 2003?
Provide a succinct answer. 1.08. What is the ratio of the Population growth (in %) of American Samoa in 2001 to that in 2002?
Give a very brief answer. 1.22. What is the ratio of the Population growth (in %) of Eritrea in 2001 to that in 2002?
Your response must be concise. 0.94. What is the ratio of the Population growth (in %) of Indonesia in 2001 to that in 2002?
Provide a short and direct response. 1.01. What is the ratio of the Population growth (in %) in Lao PDR in 2001 to that in 2002?
Your answer should be compact. 1.03. What is the ratio of the Population growth (in %) in American Samoa in 2001 to that in 2003?
Ensure brevity in your answer.  1.86. What is the ratio of the Population growth (in %) of Lao PDR in 2001 to that in 2003?
Offer a very short reply. 1.04. What is the ratio of the Population growth (in %) of American Samoa in 2002 to that in 2003?
Give a very brief answer. 1.52. What is the ratio of the Population growth (in %) in Eritrea in 2002 to that in 2003?
Offer a very short reply. 0.98. What is the ratio of the Population growth (in %) of Indonesia in 2002 to that in 2003?
Ensure brevity in your answer.  1.01. What is the ratio of the Population growth (in %) in Lao PDR in 2002 to that in 2003?
Make the answer very short. 1.02. What is the difference between the highest and the second highest Population growth (in %) of American Samoa?
Provide a short and direct response. 0.15. What is the difference between the highest and the second highest Population growth (in %) in Eritrea?
Make the answer very short. 0.09. What is the difference between the highest and the second highest Population growth (in %) of Indonesia?
Offer a terse response. 0.11. What is the difference between the highest and the second highest Population growth (in %) in Lao PDR?
Provide a succinct answer. 0.23. What is the difference between the highest and the lowest Population growth (in %) in American Samoa?
Provide a succinct answer. 2.31. What is the difference between the highest and the lowest Population growth (in %) of Eritrea?
Provide a short and direct response. 2.79. What is the difference between the highest and the lowest Population growth (in %) of Indonesia?
Ensure brevity in your answer.  1.52. What is the difference between the highest and the lowest Population growth (in %) of Lao PDR?
Your response must be concise. 1.23. 